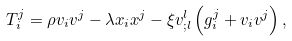<formula> <loc_0><loc_0><loc_500><loc_500>T ^ { j } _ { i } = \rho v _ { i } v ^ { j } - \lambda x _ { i } x ^ { j } - \xi v ^ { l } _ { ; l } \left ( g ^ { j } _ { i } + v _ { i } v ^ { j } \right ) ,</formula> 